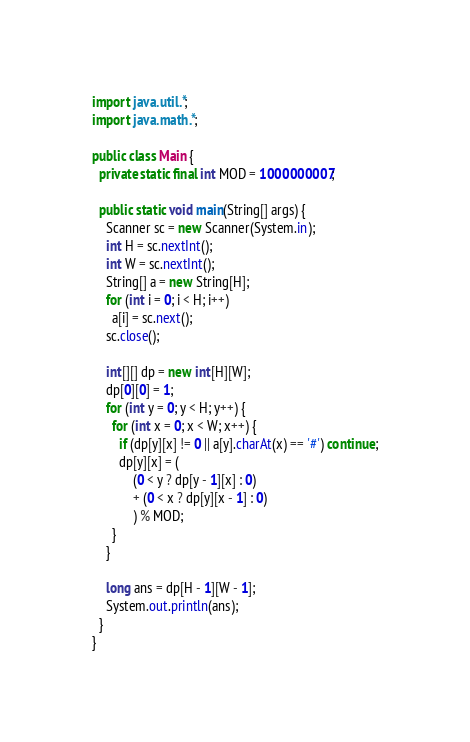Convert code to text. <code><loc_0><loc_0><loc_500><loc_500><_Java_>import java.util.*;
import java.math.*;

public class Main {
  private static final int MOD = 1000000007;

  public static void main(String[] args) {
    Scanner sc = new Scanner(System.in);
    int H = sc.nextInt();
    int W = sc.nextInt();
    String[] a = new String[H];
    for (int i = 0; i < H; i++)
      a[i] = sc.next();
    sc.close();

    int[][] dp = new int[H][W];
    dp[0][0] = 1;
    for (int y = 0; y < H; y++) {
      for (int x = 0; x < W; x++) {
        if (dp[y][x] != 0 || a[y].charAt(x) == '#') continue;
        dp[y][x] = (
            (0 < y ? dp[y - 1][x] : 0)
            + (0 < x ? dp[y][x - 1] : 0)
            ) % MOD;
      }
    }

    long ans = dp[H - 1][W - 1];
    System.out.println(ans);
  }
}</code> 